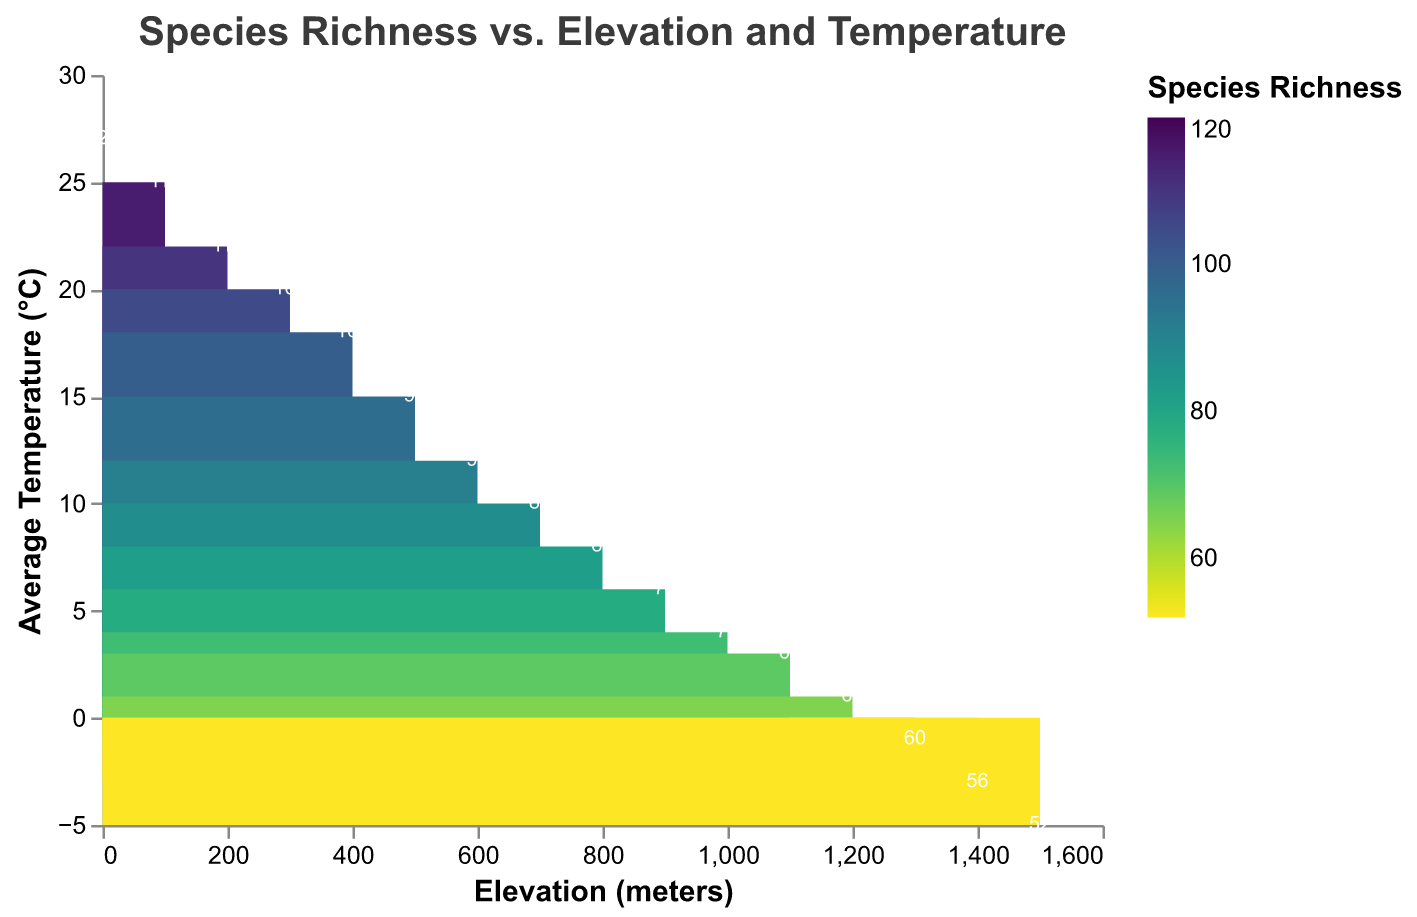What's the highest species richness observed in the figure? To determine the highest species richness, identify the data point with the maximum 'Species Richness' value. The maximum value in the figure is 120 species richness at 0 meters elevation and 27°C.
Answer: 120 What's the elevation at the lowest observed temperature? Identify the data point with the minimum 'Average Temperature'; the corresponding elevation is the answer. The lowest temperature, -5°C, is observed at 1500 meters elevation.
Answer: 1500 meters How does species richness change with increasing elevation? Observe the trend of 'Species Richness' values as 'Elevation' increases. Species richness decreases as elevation increases.
Answer: Species richness decreases What is the species richness at 700 meters elevation? Find the data point where the elevation is 700 meters and note the corresponding species richness value. The species richness at 700 meters is 87.
Answer: 87 Which temperature range corresponds to the highest species richness values? Examine the 'Average Temperature' values associated with the highest species richness values. The highest species richness (120) is at 27°C, closely followed by 115 species richness at 25°C.
Answer: 25-27°C Compare the species richness at 900 meters with that at 1100 meters. Which one is higher and by how much? Find the species richness values at 900 meters and 1100 meters, then compare. The species richness at 900 meters is 78, and at 1100 meters, it's 69. Therefore, it's higher at 900 meters by 9.
Answer: 900 meters by 9 What general trend can be observed in terms of temperature as elevation increases? Identify the pattern of 'Average Temperature' with respect to increasing 'Elevation'. As elevation increases, the temperature generally decreases.
Answer: Temperature decreases 